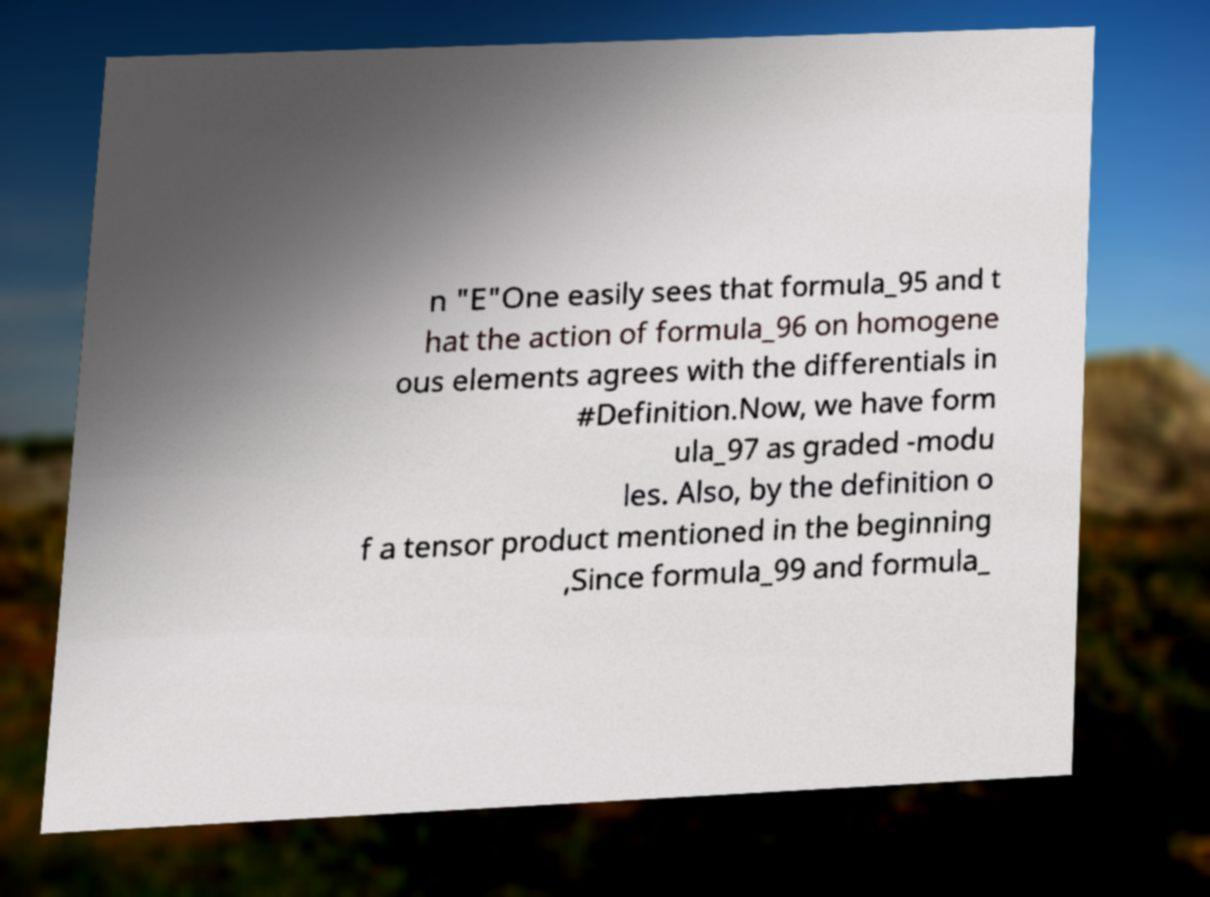Please identify and transcribe the text found in this image. n "E"One easily sees that formula_95 and t hat the action of formula_96 on homogene ous elements agrees with the differentials in #Definition.Now, we have form ula_97 as graded -modu les. Also, by the definition o f a tensor product mentioned in the beginning ,Since formula_99 and formula_ 